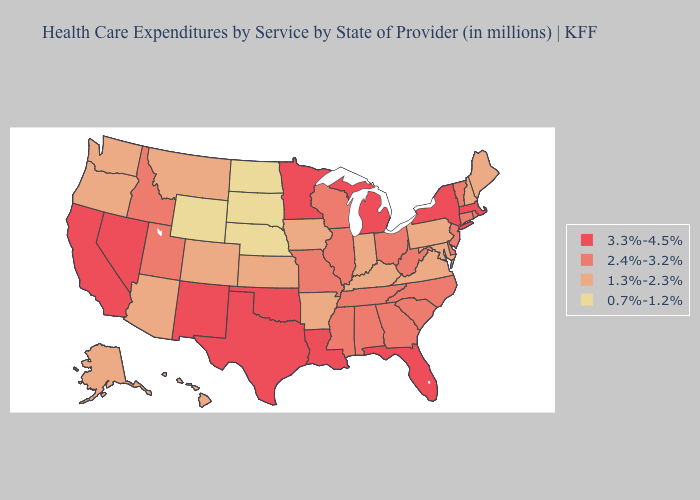What is the highest value in states that border Louisiana?
Short answer required. 3.3%-4.5%. Name the states that have a value in the range 1.3%-2.3%?
Keep it brief. Alaska, Arizona, Arkansas, Colorado, Hawaii, Indiana, Iowa, Kansas, Kentucky, Maine, Maryland, Montana, New Hampshire, Oregon, Pennsylvania, Virginia, Washington. Name the states that have a value in the range 2.4%-3.2%?
Answer briefly. Alabama, Connecticut, Delaware, Georgia, Idaho, Illinois, Mississippi, Missouri, New Jersey, North Carolina, Ohio, Rhode Island, South Carolina, Tennessee, Utah, Vermont, West Virginia, Wisconsin. Name the states that have a value in the range 0.7%-1.2%?
Keep it brief. Nebraska, North Dakota, South Dakota, Wyoming. What is the highest value in states that border North Dakota?
Be succinct. 3.3%-4.5%. What is the highest value in states that border Virginia?
Concise answer only. 2.4%-3.2%. Name the states that have a value in the range 0.7%-1.2%?
Short answer required. Nebraska, North Dakota, South Dakota, Wyoming. Which states have the lowest value in the Northeast?
Give a very brief answer. Maine, New Hampshire, Pennsylvania. Does the first symbol in the legend represent the smallest category?
Write a very short answer. No. Among the states that border South Dakota , which have the highest value?
Short answer required. Minnesota. What is the value of Mississippi?
Quick response, please. 2.4%-3.2%. What is the highest value in the South ?
Quick response, please. 3.3%-4.5%. Name the states that have a value in the range 0.7%-1.2%?
Answer briefly. Nebraska, North Dakota, South Dakota, Wyoming. Does the map have missing data?
Quick response, please. No. 